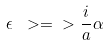<formula> <loc_0><loc_0><loc_500><loc_500>\epsilon \ > = \ > \frac { i } { a } \alpha</formula> 